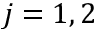<formula> <loc_0><loc_0><loc_500><loc_500>j = 1 , 2</formula> 